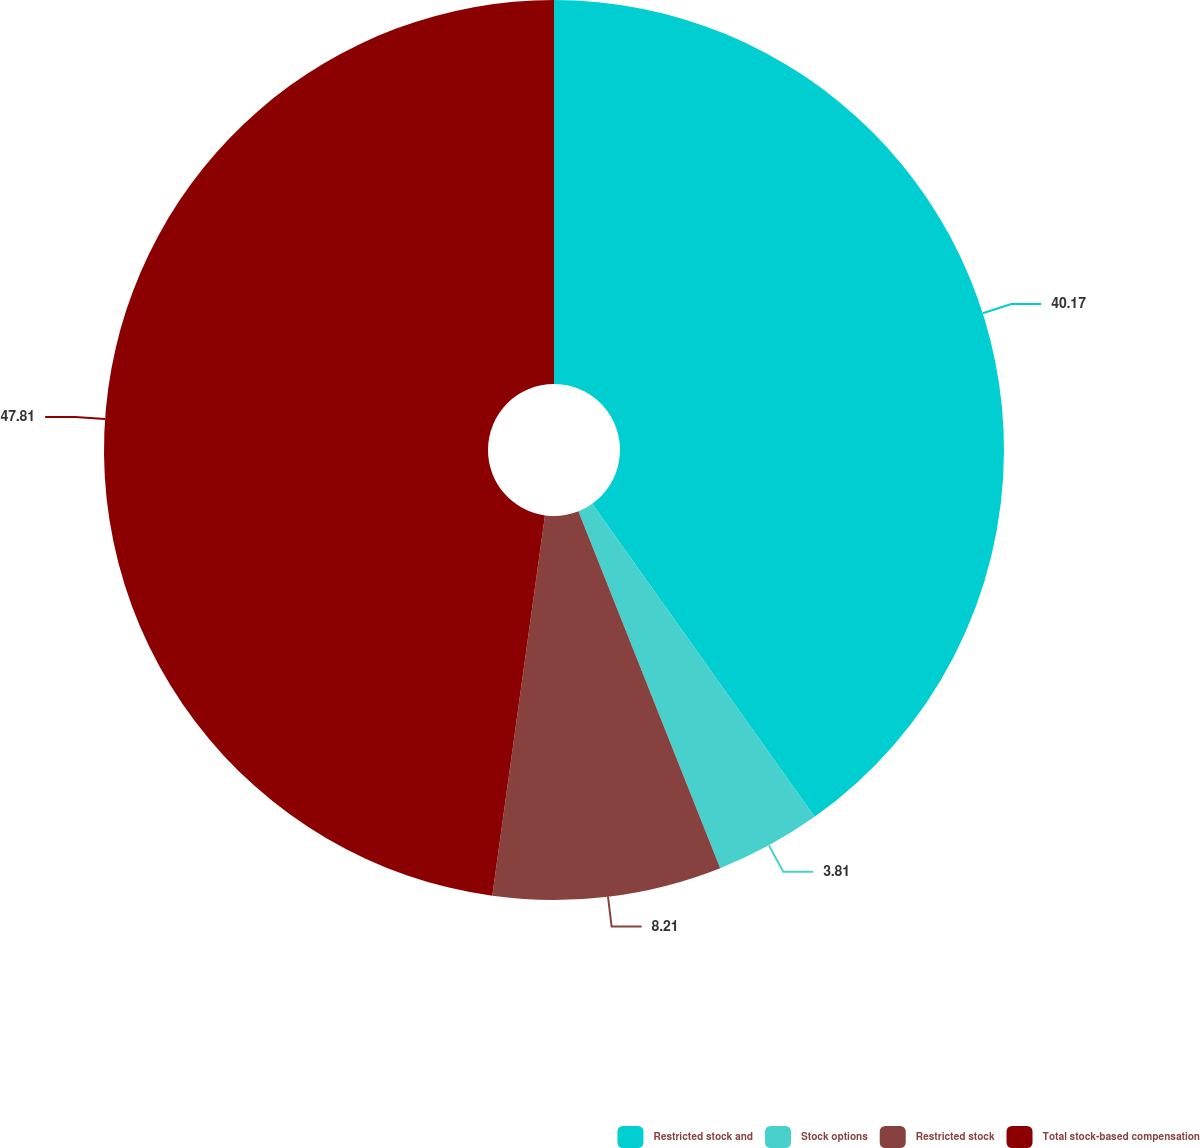Convert chart to OTSL. <chart><loc_0><loc_0><loc_500><loc_500><pie_chart><fcel>Restricted stock and<fcel>Stock options<fcel>Restricted stock<fcel>Total stock-based compensation<nl><fcel>40.17%<fcel>3.81%<fcel>8.21%<fcel>47.81%<nl></chart> 